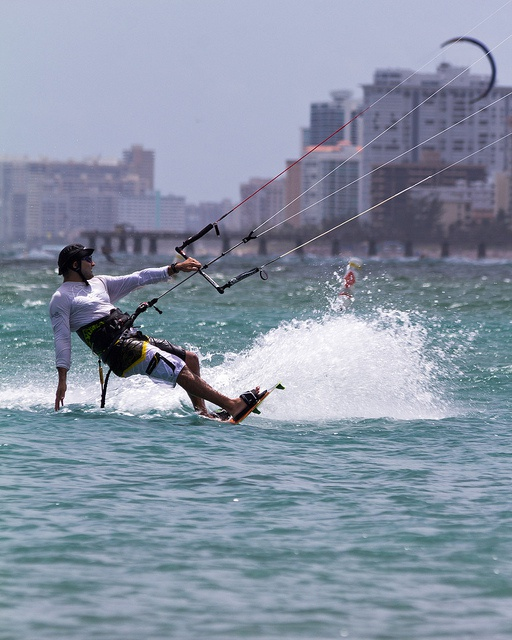Describe the objects in this image and their specific colors. I can see people in lavender, black, and gray tones and surfboard in lavender, black, maroon, lightgray, and darkgray tones in this image. 